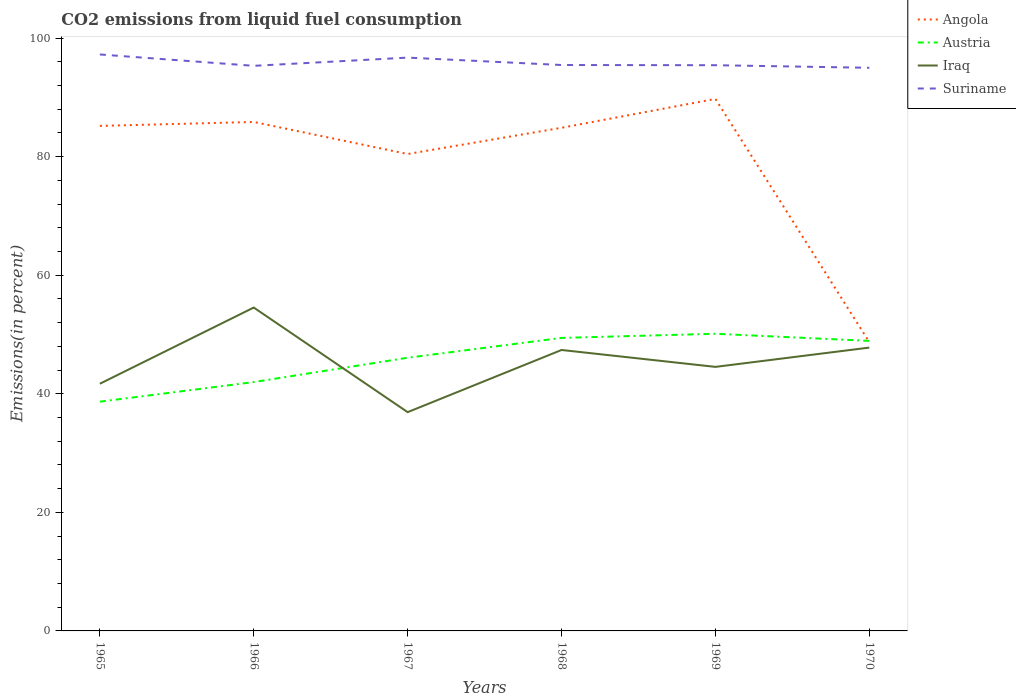Across all years, what is the maximum total CO2 emitted in Iraq?
Ensure brevity in your answer.  36.9. In which year was the total CO2 emitted in Austria maximum?
Ensure brevity in your answer.  1965. What is the total total CO2 emitted in Iraq in the graph?
Your answer should be very brief. 4.79. What is the difference between the highest and the second highest total CO2 emitted in Austria?
Make the answer very short. 11.45. Is the total CO2 emitted in Suriname strictly greater than the total CO2 emitted in Angola over the years?
Offer a terse response. No. How many years are there in the graph?
Ensure brevity in your answer.  6. What is the difference between two consecutive major ticks on the Y-axis?
Ensure brevity in your answer.  20. Does the graph contain any zero values?
Ensure brevity in your answer.  No. Does the graph contain grids?
Keep it short and to the point. No. What is the title of the graph?
Provide a short and direct response. CO2 emissions from liquid fuel consumption. What is the label or title of the X-axis?
Give a very brief answer. Years. What is the label or title of the Y-axis?
Offer a terse response. Emissions(in percent). What is the Emissions(in percent) of Angola in 1965?
Keep it short and to the point. 85.19. What is the Emissions(in percent) in Austria in 1965?
Offer a terse response. 38.67. What is the Emissions(in percent) of Iraq in 1965?
Keep it short and to the point. 41.69. What is the Emissions(in percent) in Suriname in 1965?
Give a very brief answer. 97.24. What is the Emissions(in percent) of Angola in 1966?
Provide a succinct answer. 85.85. What is the Emissions(in percent) of Austria in 1966?
Your answer should be very brief. 41.98. What is the Emissions(in percent) in Iraq in 1966?
Your answer should be compact. 54.55. What is the Emissions(in percent) in Suriname in 1966?
Offer a terse response. 95.32. What is the Emissions(in percent) in Angola in 1967?
Offer a terse response. 80.44. What is the Emissions(in percent) in Austria in 1967?
Your answer should be compact. 46.08. What is the Emissions(in percent) of Iraq in 1967?
Give a very brief answer. 36.9. What is the Emissions(in percent) in Suriname in 1967?
Provide a short and direct response. 96.7. What is the Emissions(in percent) in Angola in 1968?
Your answer should be very brief. 84.87. What is the Emissions(in percent) in Austria in 1968?
Offer a very short reply. 49.42. What is the Emissions(in percent) in Iraq in 1968?
Offer a very short reply. 47.39. What is the Emissions(in percent) in Suriname in 1968?
Offer a very short reply. 95.45. What is the Emissions(in percent) of Angola in 1969?
Keep it short and to the point. 89.74. What is the Emissions(in percent) in Austria in 1969?
Keep it short and to the point. 50.12. What is the Emissions(in percent) of Iraq in 1969?
Offer a very short reply. 44.54. What is the Emissions(in percent) of Suriname in 1969?
Your answer should be compact. 95.42. What is the Emissions(in percent) of Angola in 1970?
Provide a succinct answer. 48.72. What is the Emissions(in percent) in Austria in 1970?
Offer a terse response. 48.92. What is the Emissions(in percent) in Iraq in 1970?
Offer a terse response. 47.79. What is the Emissions(in percent) in Suriname in 1970?
Your response must be concise. 94.99. Across all years, what is the maximum Emissions(in percent) in Angola?
Give a very brief answer. 89.74. Across all years, what is the maximum Emissions(in percent) of Austria?
Offer a very short reply. 50.12. Across all years, what is the maximum Emissions(in percent) of Iraq?
Give a very brief answer. 54.55. Across all years, what is the maximum Emissions(in percent) of Suriname?
Give a very brief answer. 97.24. Across all years, what is the minimum Emissions(in percent) in Angola?
Keep it short and to the point. 48.72. Across all years, what is the minimum Emissions(in percent) of Austria?
Your answer should be very brief. 38.67. Across all years, what is the minimum Emissions(in percent) in Iraq?
Provide a succinct answer. 36.9. Across all years, what is the minimum Emissions(in percent) in Suriname?
Provide a short and direct response. 94.99. What is the total Emissions(in percent) in Angola in the graph?
Your answer should be very brief. 474.8. What is the total Emissions(in percent) in Austria in the graph?
Provide a succinct answer. 275.19. What is the total Emissions(in percent) of Iraq in the graph?
Your answer should be very brief. 272.86. What is the total Emissions(in percent) of Suriname in the graph?
Offer a terse response. 575.12. What is the difference between the Emissions(in percent) of Angola in 1965 and that in 1966?
Provide a succinct answer. -0.66. What is the difference between the Emissions(in percent) in Austria in 1965 and that in 1966?
Provide a succinct answer. -3.31. What is the difference between the Emissions(in percent) of Iraq in 1965 and that in 1966?
Provide a succinct answer. -12.85. What is the difference between the Emissions(in percent) of Suriname in 1965 and that in 1966?
Provide a short and direct response. 1.92. What is the difference between the Emissions(in percent) in Angola in 1965 and that in 1967?
Ensure brevity in your answer.  4.74. What is the difference between the Emissions(in percent) in Austria in 1965 and that in 1967?
Offer a terse response. -7.41. What is the difference between the Emissions(in percent) of Iraq in 1965 and that in 1967?
Your response must be concise. 4.79. What is the difference between the Emissions(in percent) in Suriname in 1965 and that in 1967?
Offer a terse response. 0.53. What is the difference between the Emissions(in percent) in Angola in 1965 and that in 1968?
Ensure brevity in your answer.  0.32. What is the difference between the Emissions(in percent) in Austria in 1965 and that in 1968?
Ensure brevity in your answer.  -10.76. What is the difference between the Emissions(in percent) of Iraq in 1965 and that in 1968?
Keep it short and to the point. -5.69. What is the difference between the Emissions(in percent) in Suriname in 1965 and that in 1968?
Give a very brief answer. 1.78. What is the difference between the Emissions(in percent) in Angola in 1965 and that in 1969?
Make the answer very short. -4.55. What is the difference between the Emissions(in percent) in Austria in 1965 and that in 1969?
Offer a very short reply. -11.45. What is the difference between the Emissions(in percent) of Iraq in 1965 and that in 1969?
Your answer should be very brief. -2.84. What is the difference between the Emissions(in percent) of Suriname in 1965 and that in 1969?
Your answer should be very brief. 1.81. What is the difference between the Emissions(in percent) of Angola in 1965 and that in 1970?
Offer a terse response. 36.46. What is the difference between the Emissions(in percent) in Austria in 1965 and that in 1970?
Provide a succinct answer. -10.25. What is the difference between the Emissions(in percent) in Iraq in 1965 and that in 1970?
Make the answer very short. -6.1. What is the difference between the Emissions(in percent) in Suriname in 1965 and that in 1970?
Provide a short and direct response. 2.25. What is the difference between the Emissions(in percent) in Angola in 1966 and that in 1967?
Make the answer very short. 5.41. What is the difference between the Emissions(in percent) in Austria in 1966 and that in 1967?
Give a very brief answer. -4.1. What is the difference between the Emissions(in percent) of Iraq in 1966 and that in 1967?
Give a very brief answer. 17.64. What is the difference between the Emissions(in percent) in Suriname in 1966 and that in 1967?
Provide a succinct answer. -1.39. What is the difference between the Emissions(in percent) in Angola in 1966 and that in 1968?
Your response must be concise. 0.98. What is the difference between the Emissions(in percent) of Austria in 1966 and that in 1968?
Provide a short and direct response. -7.45. What is the difference between the Emissions(in percent) of Iraq in 1966 and that in 1968?
Ensure brevity in your answer.  7.16. What is the difference between the Emissions(in percent) of Suriname in 1966 and that in 1968?
Provide a short and direct response. -0.14. What is the difference between the Emissions(in percent) in Angola in 1966 and that in 1969?
Offer a very short reply. -3.89. What is the difference between the Emissions(in percent) in Austria in 1966 and that in 1969?
Your response must be concise. -8.15. What is the difference between the Emissions(in percent) of Iraq in 1966 and that in 1969?
Your response must be concise. 10.01. What is the difference between the Emissions(in percent) of Suriname in 1966 and that in 1969?
Keep it short and to the point. -0.1. What is the difference between the Emissions(in percent) in Angola in 1966 and that in 1970?
Offer a terse response. 37.13. What is the difference between the Emissions(in percent) of Austria in 1966 and that in 1970?
Your answer should be very brief. -6.95. What is the difference between the Emissions(in percent) of Iraq in 1966 and that in 1970?
Provide a short and direct response. 6.76. What is the difference between the Emissions(in percent) in Suriname in 1966 and that in 1970?
Provide a short and direct response. 0.33. What is the difference between the Emissions(in percent) in Angola in 1967 and that in 1968?
Make the answer very short. -4.43. What is the difference between the Emissions(in percent) in Austria in 1967 and that in 1968?
Offer a very short reply. -3.35. What is the difference between the Emissions(in percent) of Iraq in 1967 and that in 1968?
Give a very brief answer. -10.49. What is the difference between the Emissions(in percent) in Suriname in 1967 and that in 1968?
Offer a very short reply. 1.25. What is the difference between the Emissions(in percent) of Angola in 1967 and that in 1969?
Keep it short and to the point. -9.29. What is the difference between the Emissions(in percent) of Austria in 1967 and that in 1969?
Ensure brevity in your answer.  -4.05. What is the difference between the Emissions(in percent) in Iraq in 1967 and that in 1969?
Your answer should be compact. -7.64. What is the difference between the Emissions(in percent) of Suriname in 1967 and that in 1969?
Keep it short and to the point. 1.28. What is the difference between the Emissions(in percent) in Angola in 1967 and that in 1970?
Your response must be concise. 31.72. What is the difference between the Emissions(in percent) in Austria in 1967 and that in 1970?
Ensure brevity in your answer.  -2.84. What is the difference between the Emissions(in percent) in Iraq in 1967 and that in 1970?
Your answer should be compact. -10.89. What is the difference between the Emissions(in percent) in Suriname in 1967 and that in 1970?
Your answer should be compact. 1.71. What is the difference between the Emissions(in percent) of Angola in 1968 and that in 1969?
Give a very brief answer. -4.87. What is the difference between the Emissions(in percent) in Austria in 1968 and that in 1969?
Your response must be concise. -0.7. What is the difference between the Emissions(in percent) in Iraq in 1968 and that in 1969?
Offer a very short reply. 2.85. What is the difference between the Emissions(in percent) of Suriname in 1968 and that in 1969?
Offer a terse response. 0.03. What is the difference between the Emissions(in percent) in Angola in 1968 and that in 1970?
Provide a succinct answer. 36.15. What is the difference between the Emissions(in percent) of Austria in 1968 and that in 1970?
Offer a terse response. 0.5. What is the difference between the Emissions(in percent) of Iraq in 1968 and that in 1970?
Your response must be concise. -0.4. What is the difference between the Emissions(in percent) in Suriname in 1968 and that in 1970?
Provide a succinct answer. 0.47. What is the difference between the Emissions(in percent) in Angola in 1969 and that in 1970?
Your response must be concise. 41.02. What is the difference between the Emissions(in percent) of Austria in 1969 and that in 1970?
Your answer should be compact. 1.2. What is the difference between the Emissions(in percent) of Iraq in 1969 and that in 1970?
Your answer should be very brief. -3.25. What is the difference between the Emissions(in percent) of Suriname in 1969 and that in 1970?
Your response must be concise. 0.43. What is the difference between the Emissions(in percent) of Angola in 1965 and the Emissions(in percent) of Austria in 1966?
Give a very brief answer. 43.21. What is the difference between the Emissions(in percent) in Angola in 1965 and the Emissions(in percent) in Iraq in 1966?
Give a very brief answer. 30.64. What is the difference between the Emissions(in percent) in Angola in 1965 and the Emissions(in percent) in Suriname in 1966?
Provide a succinct answer. -10.13. What is the difference between the Emissions(in percent) in Austria in 1965 and the Emissions(in percent) in Iraq in 1966?
Keep it short and to the point. -15.88. What is the difference between the Emissions(in percent) in Austria in 1965 and the Emissions(in percent) in Suriname in 1966?
Offer a terse response. -56.65. What is the difference between the Emissions(in percent) of Iraq in 1965 and the Emissions(in percent) of Suriname in 1966?
Ensure brevity in your answer.  -53.62. What is the difference between the Emissions(in percent) in Angola in 1965 and the Emissions(in percent) in Austria in 1967?
Provide a short and direct response. 39.11. What is the difference between the Emissions(in percent) of Angola in 1965 and the Emissions(in percent) of Iraq in 1967?
Provide a succinct answer. 48.28. What is the difference between the Emissions(in percent) of Angola in 1965 and the Emissions(in percent) of Suriname in 1967?
Keep it short and to the point. -11.52. What is the difference between the Emissions(in percent) of Austria in 1965 and the Emissions(in percent) of Iraq in 1967?
Give a very brief answer. 1.77. What is the difference between the Emissions(in percent) of Austria in 1965 and the Emissions(in percent) of Suriname in 1967?
Ensure brevity in your answer.  -58.03. What is the difference between the Emissions(in percent) in Iraq in 1965 and the Emissions(in percent) in Suriname in 1967?
Your answer should be compact. -55.01. What is the difference between the Emissions(in percent) in Angola in 1965 and the Emissions(in percent) in Austria in 1968?
Provide a succinct answer. 35.76. What is the difference between the Emissions(in percent) of Angola in 1965 and the Emissions(in percent) of Iraq in 1968?
Keep it short and to the point. 37.8. What is the difference between the Emissions(in percent) in Angola in 1965 and the Emissions(in percent) in Suriname in 1968?
Keep it short and to the point. -10.27. What is the difference between the Emissions(in percent) in Austria in 1965 and the Emissions(in percent) in Iraq in 1968?
Your answer should be very brief. -8.72. What is the difference between the Emissions(in percent) in Austria in 1965 and the Emissions(in percent) in Suriname in 1968?
Offer a terse response. -56.79. What is the difference between the Emissions(in percent) in Iraq in 1965 and the Emissions(in percent) in Suriname in 1968?
Make the answer very short. -53.76. What is the difference between the Emissions(in percent) in Angola in 1965 and the Emissions(in percent) in Austria in 1969?
Offer a terse response. 35.06. What is the difference between the Emissions(in percent) of Angola in 1965 and the Emissions(in percent) of Iraq in 1969?
Offer a very short reply. 40.65. What is the difference between the Emissions(in percent) in Angola in 1965 and the Emissions(in percent) in Suriname in 1969?
Ensure brevity in your answer.  -10.24. What is the difference between the Emissions(in percent) in Austria in 1965 and the Emissions(in percent) in Iraq in 1969?
Your response must be concise. -5.87. What is the difference between the Emissions(in percent) in Austria in 1965 and the Emissions(in percent) in Suriname in 1969?
Offer a terse response. -56.75. What is the difference between the Emissions(in percent) in Iraq in 1965 and the Emissions(in percent) in Suriname in 1969?
Ensure brevity in your answer.  -53.73. What is the difference between the Emissions(in percent) of Angola in 1965 and the Emissions(in percent) of Austria in 1970?
Provide a succinct answer. 36.26. What is the difference between the Emissions(in percent) in Angola in 1965 and the Emissions(in percent) in Iraq in 1970?
Provide a short and direct response. 37.39. What is the difference between the Emissions(in percent) of Angola in 1965 and the Emissions(in percent) of Suriname in 1970?
Offer a terse response. -9.8. What is the difference between the Emissions(in percent) of Austria in 1965 and the Emissions(in percent) of Iraq in 1970?
Give a very brief answer. -9.12. What is the difference between the Emissions(in percent) of Austria in 1965 and the Emissions(in percent) of Suriname in 1970?
Your answer should be compact. -56.32. What is the difference between the Emissions(in percent) of Iraq in 1965 and the Emissions(in percent) of Suriname in 1970?
Offer a terse response. -53.3. What is the difference between the Emissions(in percent) of Angola in 1966 and the Emissions(in percent) of Austria in 1967?
Provide a succinct answer. 39.77. What is the difference between the Emissions(in percent) in Angola in 1966 and the Emissions(in percent) in Iraq in 1967?
Give a very brief answer. 48.95. What is the difference between the Emissions(in percent) in Angola in 1966 and the Emissions(in percent) in Suriname in 1967?
Give a very brief answer. -10.85. What is the difference between the Emissions(in percent) in Austria in 1966 and the Emissions(in percent) in Iraq in 1967?
Offer a terse response. 5.07. What is the difference between the Emissions(in percent) of Austria in 1966 and the Emissions(in percent) of Suriname in 1967?
Your answer should be very brief. -54.73. What is the difference between the Emissions(in percent) in Iraq in 1966 and the Emissions(in percent) in Suriname in 1967?
Provide a succinct answer. -42.16. What is the difference between the Emissions(in percent) of Angola in 1966 and the Emissions(in percent) of Austria in 1968?
Offer a very short reply. 36.42. What is the difference between the Emissions(in percent) in Angola in 1966 and the Emissions(in percent) in Iraq in 1968?
Ensure brevity in your answer.  38.46. What is the difference between the Emissions(in percent) in Angola in 1966 and the Emissions(in percent) in Suriname in 1968?
Your response must be concise. -9.61. What is the difference between the Emissions(in percent) of Austria in 1966 and the Emissions(in percent) of Iraq in 1968?
Your answer should be compact. -5.41. What is the difference between the Emissions(in percent) in Austria in 1966 and the Emissions(in percent) in Suriname in 1968?
Your answer should be very brief. -53.48. What is the difference between the Emissions(in percent) of Iraq in 1966 and the Emissions(in percent) of Suriname in 1968?
Your response must be concise. -40.91. What is the difference between the Emissions(in percent) in Angola in 1966 and the Emissions(in percent) in Austria in 1969?
Your answer should be very brief. 35.73. What is the difference between the Emissions(in percent) in Angola in 1966 and the Emissions(in percent) in Iraq in 1969?
Provide a succinct answer. 41.31. What is the difference between the Emissions(in percent) in Angola in 1966 and the Emissions(in percent) in Suriname in 1969?
Keep it short and to the point. -9.57. What is the difference between the Emissions(in percent) of Austria in 1966 and the Emissions(in percent) of Iraq in 1969?
Your response must be concise. -2.56. What is the difference between the Emissions(in percent) in Austria in 1966 and the Emissions(in percent) in Suriname in 1969?
Provide a succinct answer. -53.45. What is the difference between the Emissions(in percent) of Iraq in 1966 and the Emissions(in percent) of Suriname in 1969?
Offer a very short reply. -40.88. What is the difference between the Emissions(in percent) of Angola in 1966 and the Emissions(in percent) of Austria in 1970?
Provide a short and direct response. 36.93. What is the difference between the Emissions(in percent) in Angola in 1966 and the Emissions(in percent) in Iraq in 1970?
Offer a terse response. 38.06. What is the difference between the Emissions(in percent) of Angola in 1966 and the Emissions(in percent) of Suriname in 1970?
Give a very brief answer. -9.14. What is the difference between the Emissions(in percent) in Austria in 1966 and the Emissions(in percent) in Iraq in 1970?
Provide a succinct answer. -5.81. What is the difference between the Emissions(in percent) in Austria in 1966 and the Emissions(in percent) in Suriname in 1970?
Give a very brief answer. -53.01. What is the difference between the Emissions(in percent) in Iraq in 1966 and the Emissions(in percent) in Suriname in 1970?
Give a very brief answer. -40.44. What is the difference between the Emissions(in percent) in Angola in 1967 and the Emissions(in percent) in Austria in 1968?
Keep it short and to the point. 31.02. What is the difference between the Emissions(in percent) in Angola in 1967 and the Emissions(in percent) in Iraq in 1968?
Offer a terse response. 33.06. What is the difference between the Emissions(in percent) of Angola in 1967 and the Emissions(in percent) of Suriname in 1968?
Provide a succinct answer. -15.01. What is the difference between the Emissions(in percent) in Austria in 1967 and the Emissions(in percent) in Iraq in 1968?
Make the answer very short. -1.31. What is the difference between the Emissions(in percent) of Austria in 1967 and the Emissions(in percent) of Suriname in 1968?
Keep it short and to the point. -49.38. What is the difference between the Emissions(in percent) of Iraq in 1967 and the Emissions(in percent) of Suriname in 1968?
Offer a very short reply. -58.55. What is the difference between the Emissions(in percent) in Angola in 1967 and the Emissions(in percent) in Austria in 1969?
Your answer should be compact. 30.32. What is the difference between the Emissions(in percent) in Angola in 1967 and the Emissions(in percent) in Iraq in 1969?
Your answer should be very brief. 35.9. What is the difference between the Emissions(in percent) of Angola in 1967 and the Emissions(in percent) of Suriname in 1969?
Offer a very short reply. -14.98. What is the difference between the Emissions(in percent) of Austria in 1967 and the Emissions(in percent) of Iraq in 1969?
Offer a terse response. 1.54. What is the difference between the Emissions(in percent) in Austria in 1967 and the Emissions(in percent) in Suriname in 1969?
Give a very brief answer. -49.34. What is the difference between the Emissions(in percent) of Iraq in 1967 and the Emissions(in percent) of Suriname in 1969?
Ensure brevity in your answer.  -58.52. What is the difference between the Emissions(in percent) of Angola in 1967 and the Emissions(in percent) of Austria in 1970?
Provide a succinct answer. 31.52. What is the difference between the Emissions(in percent) in Angola in 1967 and the Emissions(in percent) in Iraq in 1970?
Your response must be concise. 32.65. What is the difference between the Emissions(in percent) in Angola in 1967 and the Emissions(in percent) in Suriname in 1970?
Offer a terse response. -14.55. What is the difference between the Emissions(in percent) of Austria in 1967 and the Emissions(in percent) of Iraq in 1970?
Keep it short and to the point. -1.71. What is the difference between the Emissions(in percent) in Austria in 1967 and the Emissions(in percent) in Suriname in 1970?
Your response must be concise. -48.91. What is the difference between the Emissions(in percent) of Iraq in 1967 and the Emissions(in percent) of Suriname in 1970?
Ensure brevity in your answer.  -58.09. What is the difference between the Emissions(in percent) in Angola in 1968 and the Emissions(in percent) in Austria in 1969?
Ensure brevity in your answer.  34.75. What is the difference between the Emissions(in percent) of Angola in 1968 and the Emissions(in percent) of Iraq in 1969?
Provide a short and direct response. 40.33. What is the difference between the Emissions(in percent) of Angola in 1968 and the Emissions(in percent) of Suriname in 1969?
Ensure brevity in your answer.  -10.55. What is the difference between the Emissions(in percent) of Austria in 1968 and the Emissions(in percent) of Iraq in 1969?
Make the answer very short. 4.89. What is the difference between the Emissions(in percent) of Austria in 1968 and the Emissions(in percent) of Suriname in 1969?
Provide a short and direct response. -46. What is the difference between the Emissions(in percent) of Iraq in 1968 and the Emissions(in percent) of Suriname in 1969?
Make the answer very short. -48.03. What is the difference between the Emissions(in percent) of Angola in 1968 and the Emissions(in percent) of Austria in 1970?
Give a very brief answer. 35.95. What is the difference between the Emissions(in percent) in Angola in 1968 and the Emissions(in percent) in Iraq in 1970?
Your answer should be very brief. 37.08. What is the difference between the Emissions(in percent) of Angola in 1968 and the Emissions(in percent) of Suriname in 1970?
Ensure brevity in your answer.  -10.12. What is the difference between the Emissions(in percent) of Austria in 1968 and the Emissions(in percent) of Iraq in 1970?
Offer a terse response. 1.63. What is the difference between the Emissions(in percent) of Austria in 1968 and the Emissions(in percent) of Suriname in 1970?
Offer a terse response. -45.56. What is the difference between the Emissions(in percent) of Iraq in 1968 and the Emissions(in percent) of Suriname in 1970?
Provide a short and direct response. -47.6. What is the difference between the Emissions(in percent) in Angola in 1969 and the Emissions(in percent) in Austria in 1970?
Ensure brevity in your answer.  40.81. What is the difference between the Emissions(in percent) of Angola in 1969 and the Emissions(in percent) of Iraq in 1970?
Make the answer very short. 41.95. What is the difference between the Emissions(in percent) of Angola in 1969 and the Emissions(in percent) of Suriname in 1970?
Keep it short and to the point. -5.25. What is the difference between the Emissions(in percent) in Austria in 1969 and the Emissions(in percent) in Iraq in 1970?
Your answer should be compact. 2.33. What is the difference between the Emissions(in percent) of Austria in 1969 and the Emissions(in percent) of Suriname in 1970?
Your answer should be very brief. -44.87. What is the difference between the Emissions(in percent) in Iraq in 1969 and the Emissions(in percent) in Suriname in 1970?
Keep it short and to the point. -50.45. What is the average Emissions(in percent) in Angola per year?
Ensure brevity in your answer.  79.13. What is the average Emissions(in percent) in Austria per year?
Provide a succinct answer. 45.87. What is the average Emissions(in percent) in Iraq per year?
Offer a terse response. 45.48. What is the average Emissions(in percent) of Suriname per year?
Ensure brevity in your answer.  95.85. In the year 1965, what is the difference between the Emissions(in percent) of Angola and Emissions(in percent) of Austria?
Ensure brevity in your answer.  46.52. In the year 1965, what is the difference between the Emissions(in percent) in Angola and Emissions(in percent) in Iraq?
Offer a very short reply. 43.49. In the year 1965, what is the difference between the Emissions(in percent) of Angola and Emissions(in percent) of Suriname?
Your answer should be very brief. -12.05. In the year 1965, what is the difference between the Emissions(in percent) in Austria and Emissions(in percent) in Iraq?
Provide a short and direct response. -3.02. In the year 1965, what is the difference between the Emissions(in percent) of Austria and Emissions(in percent) of Suriname?
Your answer should be compact. -58.57. In the year 1965, what is the difference between the Emissions(in percent) in Iraq and Emissions(in percent) in Suriname?
Keep it short and to the point. -55.54. In the year 1966, what is the difference between the Emissions(in percent) of Angola and Emissions(in percent) of Austria?
Give a very brief answer. 43.87. In the year 1966, what is the difference between the Emissions(in percent) in Angola and Emissions(in percent) in Iraq?
Provide a short and direct response. 31.3. In the year 1966, what is the difference between the Emissions(in percent) of Angola and Emissions(in percent) of Suriname?
Give a very brief answer. -9.47. In the year 1966, what is the difference between the Emissions(in percent) in Austria and Emissions(in percent) in Iraq?
Offer a very short reply. -12.57. In the year 1966, what is the difference between the Emissions(in percent) in Austria and Emissions(in percent) in Suriname?
Provide a succinct answer. -53.34. In the year 1966, what is the difference between the Emissions(in percent) of Iraq and Emissions(in percent) of Suriname?
Provide a succinct answer. -40.77. In the year 1967, what is the difference between the Emissions(in percent) in Angola and Emissions(in percent) in Austria?
Keep it short and to the point. 34.37. In the year 1967, what is the difference between the Emissions(in percent) in Angola and Emissions(in percent) in Iraq?
Your answer should be compact. 43.54. In the year 1967, what is the difference between the Emissions(in percent) of Angola and Emissions(in percent) of Suriname?
Provide a short and direct response. -16.26. In the year 1967, what is the difference between the Emissions(in percent) in Austria and Emissions(in percent) in Iraq?
Your answer should be compact. 9.18. In the year 1967, what is the difference between the Emissions(in percent) of Austria and Emissions(in percent) of Suriname?
Make the answer very short. -50.63. In the year 1967, what is the difference between the Emissions(in percent) in Iraq and Emissions(in percent) in Suriname?
Ensure brevity in your answer.  -59.8. In the year 1968, what is the difference between the Emissions(in percent) in Angola and Emissions(in percent) in Austria?
Ensure brevity in your answer.  35.44. In the year 1968, what is the difference between the Emissions(in percent) in Angola and Emissions(in percent) in Iraq?
Ensure brevity in your answer.  37.48. In the year 1968, what is the difference between the Emissions(in percent) in Angola and Emissions(in percent) in Suriname?
Your response must be concise. -10.59. In the year 1968, what is the difference between the Emissions(in percent) of Austria and Emissions(in percent) of Iraq?
Ensure brevity in your answer.  2.04. In the year 1968, what is the difference between the Emissions(in percent) of Austria and Emissions(in percent) of Suriname?
Give a very brief answer. -46.03. In the year 1968, what is the difference between the Emissions(in percent) in Iraq and Emissions(in percent) in Suriname?
Ensure brevity in your answer.  -48.07. In the year 1969, what is the difference between the Emissions(in percent) in Angola and Emissions(in percent) in Austria?
Provide a short and direct response. 39.61. In the year 1969, what is the difference between the Emissions(in percent) in Angola and Emissions(in percent) in Iraq?
Offer a terse response. 45.2. In the year 1969, what is the difference between the Emissions(in percent) of Angola and Emissions(in percent) of Suriname?
Keep it short and to the point. -5.68. In the year 1969, what is the difference between the Emissions(in percent) of Austria and Emissions(in percent) of Iraq?
Your answer should be compact. 5.58. In the year 1969, what is the difference between the Emissions(in percent) in Austria and Emissions(in percent) in Suriname?
Your answer should be compact. -45.3. In the year 1969, what is the difference between the Emissions(in percent) of Iraq and Emissions(in percent) of Suriname?
Your answer should be compact. -50.88. In the year 1970, what is the difference between the Emissions(in percent) of Angola and Emissions(in percent) of Austria?
Make the answer very short. -0.2. In the year 1970, what is the difference between the Emissions(in percent) of Angola and Emissions(in percent) of Iraq?
Your answer should be very brief. 0.93. In the year 1970, what is the difference between the Emissions(in percent) in Angola and Emissions(in percent) in Suriname?
Offer a very short reply. -46.27. In the year 1970, what is the difference between the Emissions(in percent) of Austria and Emissions(in percent) of Iraq?
Offer a terse response. 1.13. In the year 1970, what is the difference between the Emissions(in percent) in Austria and Emissions(in percent) in Suriname?
Ensure brevity in your answer.  -46.07. In the year 1970, what is the difference between the Emissions(in percent) of Iraq and Emissions(in percent) of Suriname?
Provide a short and direct response. -47.2. What is the ratio of the Emissions(in percent) in Angola in 1965 to that in 1966?
Give a very brief answer. 0.99. What is the ratio of the Emissions(in percent) of Austria in 1965 to that in 1966?
Make the answer very short. 0.92. What is the ratio of the Emissions(in percent) in Iraq in 1965 to that in 1966?
Make the answer very short. 0.76. What is the ratio of the Emissions(in percent) in Suriname in 1965 to that in 1966?
Offer a terse response. 1.02. What is the ratio of the Emissions(in percent) in Angola in 1965 to that in 1967?
Offer a terse response. 1.06. What is the ratio of the Emissions(in percent) of Austria in 1965 to that in 1967?
Your answer should be compact. 0.84. What is the ratio of the Emissions(in percent) of Iraq in 1965 to that in 1967?
Your answer should be very brief. 1.13. What is the ratio of the Emissions(in percent) in Suriname in 1965 to that in 1967?
Ensure brevity in your answer.  1.01. What is the ratio of the Emissions(in percent) of Angola in 1965 to that in 1968?
Your response must be concise. 1. What is the ratio of the Emissions(in percent) in Austria in 1965 to that in 1968?
Make the answer very short. 0.78. What is the ratio of the Emissions(in percent) in Iraq in 1965 to that in 1968?
Offer a very short reply. 0.88. What is the ratio of the Emissions(in percent) in Suriname in 1965 to that in 1968?
Your answer should be compact. 1.02. What is the ratio of the Emissions(in percent) of Angola in 1965 to that in 1969?
Give a very brief answer. 0.95. What is the ratio of the Emissions(in percent) of Austria in 1965 to that in 1969?
Your response must be concise. 0.77. What is the ratio of the Emissions(in percent) of Iraq in 1965 to that in 1969?
Your answer should be very brief. 0.94. What is the ratio of the Emissions(in percent) of Angola in 1965 to that in 1970?
Make the answer very short. 1.75. What is the ratio of the Emissions(in percent) of Austria in 1965 to that in 1970?
Keep it short and to the point. 0.79. What is the ratio of the Emissions(in percent) of Iraq in 1965 to that in 1970?
Ensure brevity in your answer.  0.87. What is the ratio of the Emissions(in percent) in Suriname in 1965 to that in 1970?
Keep it short and to the point. 1.02. What is the ratio of the Emissions(in percent) in Angola in 1966 to that in 1967?
Give a very brief answer. 1.07. What is the ratio of the Emissions(in percent) in Austria in 1966 to that in 1967?
Ensure brevity in your answer.  0.91. What is the ratio of the Emissions(in percent) in Iraq in 1966 to that in 1967?
Keep it short and to the point. 1.48. What is the ratio of the Emissions(in percent) in Suriname in 1966 to that in 1967?
Make the answer very short. 0.99. What is the ratio of the Emissions(in percent) of Angola in 1966 to that in 1968?
Provide a short and direct response. 1.01. What is the ratio of the Emissions(in percent) in Austria in 1966 to that in 1968?
Give a very brief answer. 0.85. What is the ratio of the Emissions(in percent) in Iraq in 1966 to that in 1968?
Your answer should be very brief. 1.15. What is the ratio of the Emissions(in percent) of Suriname in 1966 to that in 1968?
Your response must be concise. 1. What is the ratio of the Emissions(in percent) of Angola in 1966 to that in 1969?
Make the answer very short. 0.96. What is the ratio of the Emissions(in percent) in Austria in 1966 to that in 1969?
Give a very brief answer. 0.84. What is the ratio of the Emissions(in percent) in Iraq in 1966 to that in 1969?
Provide a succinct answer. 1.22. What is the ratio of the Emissions(in percent) in Angola in 1966 to that in 1970?
Your answer should be very brief. 1.76. What is the ratio of the Emissions(in percent) in Austria in 1966 to that in 1970?
Keep it short and to the point. 0.86. What is the ratio of the Emissions(in percent) in Iraq in 1966 to that in 1970?
Keep it short and to the point. 1.14. What is the ratio of the Emissions(in percent) of Angola in 1967 to that in 1968?
Your answer should be compact. 0.95. What is the ratio of the Emissions(in percent) of Austria in 1967 to that in 1968?
Provide a short and direct response. 0.93. What is the ratio of the Emissions(in percent) of Iraq in 1967 to that in 1968?
Make the answer very short. 0.78. What is the ratio of the Emissions(in percent) of Suriname in 1967 to that in 1968?
Your answer should be very brief. 1.01. What is the ratio of the Emissions(in percent) of Angola in 1967 to that in 1969?
Offer a terse response. 0.9. What is the ratio of the Emissions(in percent) of Austria in 1967 to that in 1969?
Offer a terse response. 0.92. What is the ratio of the Emissions(in percent) in Iraq in 1967 to that in 1969?
Offer a very short reply. 0.83. What is the ratio of the Emissions(in percent) in Suriname in 1967 to that in 1969?
Give a very brief answer. 1.01. What is the ratio of the Emissions(in percent) of Angola in 1967 to that in 1970?
Ensure brevity in your answer.  1.65. What is the ratio of the Emissions(in percent) in Austria in 1967 to that in 1970?
Make the answer very short. 0.94. What is the ratio of the Emissions(in percent) in Iraq in 1967 to that in 1970?
Provide a succinct answer. 0.77. What is the ratio of the Emissions(in percent) in Suriname in 1967 to that in 1970?
Make the answer very short. 1.02. What is the ratio of the Emissions(in percent) in Angola in 1968 to that in 1969?
Offer a terse response. 0.95. What is the ratio of the Emissions(in percent) in Austria in 1968 to that in 1969?
Make the answer very short. 0.99. What is the ratio of the Emissions(in percent) in Iraq in 1968 to that in 1969?
Keep it short and to the point. 1.06. What is the ratio of the Emissions(in percent) of Suriname in 1968 to that in 1969?
Make the answer very short. 1. What is the ratio of the Emissions(in percent) of Angola in 1968 to that in 1970?
Your answer should be compact. 1.74. What is the ratio of the Emissions(in percent) in Austria in 1968 to that in 1970?
Provide a succinct answer. 1.01. What is the ratio of the Emissions(in percent) in Iraq in 1968 to that in 1970?
Your answer should be compact. 0.99. What is the ratio of the Emissions(in percent) of Suriname in 1968 to that in 1970?
Your answer should be compact. 1. What is the ratio of the Emissions(in percent) in Angola in 1969 to that in 1970?
Give a very brief answer. 1.84. What is the ratio of the Emissions(in percent) of Austria in 1969 to that in 1970?
Your response must be concise. 1.02. What is the ratio of the Emissions(in percent) in Iraq in 1969 to that in 1970?
Keep it short and to the point. 0.93. What is the ratio of the Emissions(in percent) in Suriname in 1969 to that in 1970?
Make the answer very short. 1. What is the difference between the highest and the second highest Emissions(in percent) in Angola?
Give a very brief answer. 3.89. What is the difference between the highest and the second highest Emissions(in percent) of Austria?
Make the answer very short. 0.7. What is the difference between the highest and the second highest Emissions(in percent) of Iraq?
Ensure brevity in your answer.  6.76. What is the difference between the highest and the second highest Emissions(in percent) of Suriname?
Keep it short and to the point. 0.53. What is the difference between the highest and the lowest Emissions(in percent) of Angola?
Offer a very short reply. 41.02. What is the difference between the highest and the lowest Emissions(in percent) in Austria?
Offer a terse response. 11.45. What is the difference between the highest and the lowest Emissions(in percent) in Iraq?
Provide a short and direct response. 17.64. What is the difference between the highest and the lowest Emissions(in percent) of Suriname?
Provide a short and direct response. 2.25. 